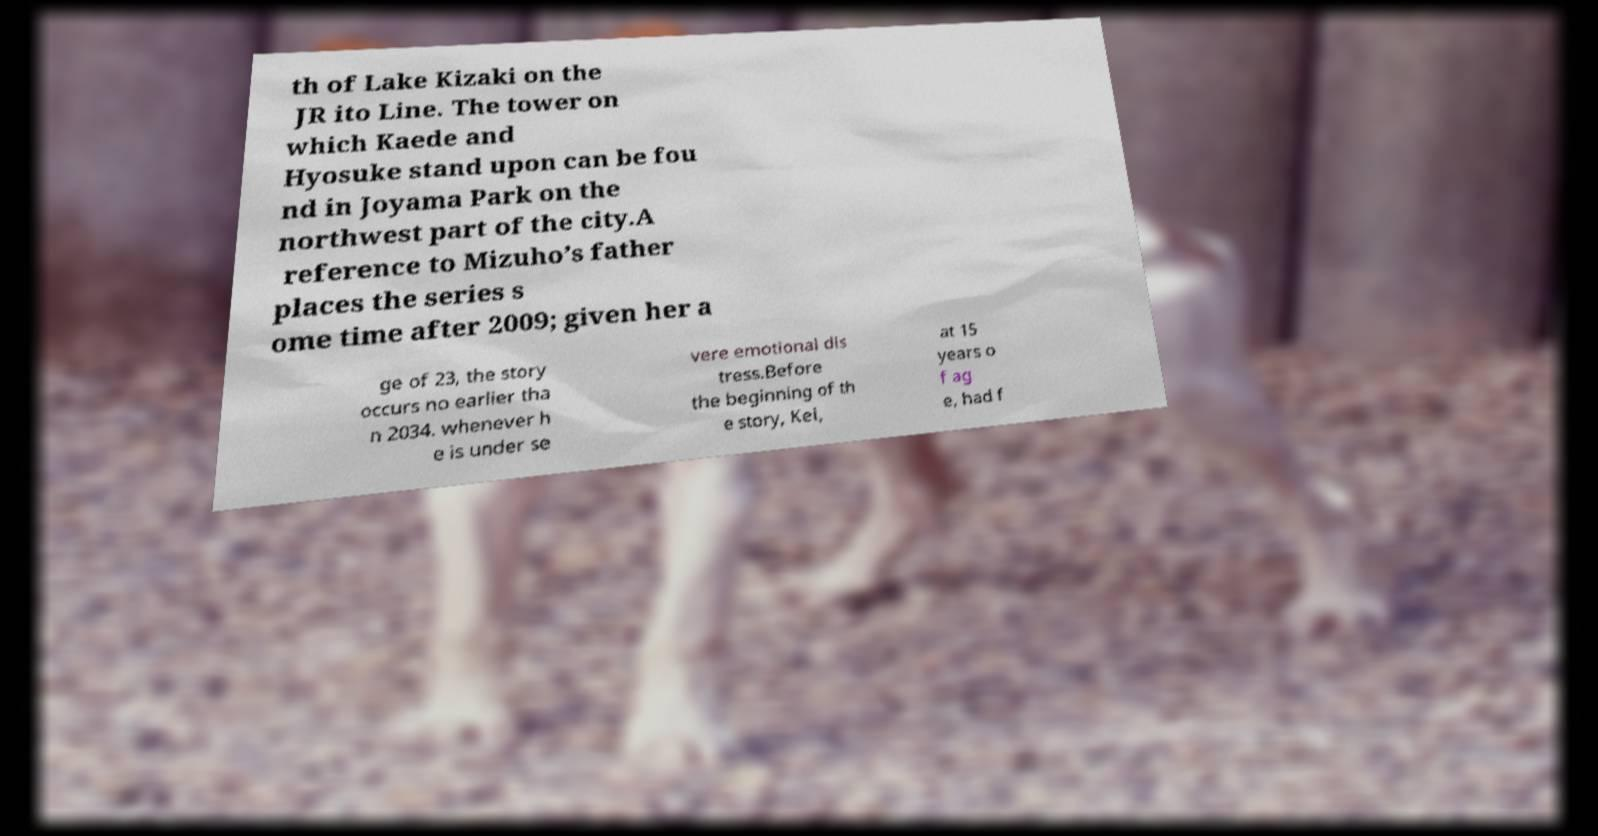I need the written content from this picture converted into text. Can you do that? th of Lake Kizaki on the JR ito Line. The tower on which Kaede and Hyosuke stand upon can be fou nd in Joyama Park on the northwest part of the city.A reference to Mizuho’s father places the series s ome time after 2009; given her a ge of 23, the story occurs no earlier tha n 2034. whenever h e is under se vere emotional dis tress.Before the beginning of th e story, Kei, at 15 years o f ag e, had f 